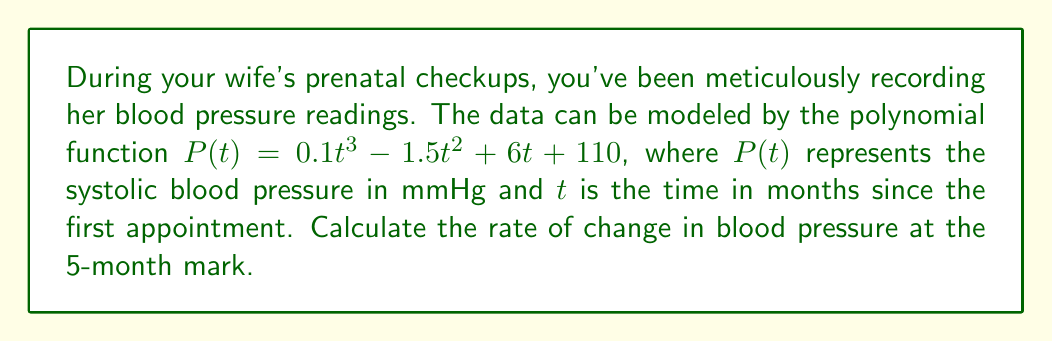Provide a solution to this math problem. To find the rate of change in blood pressure at a specific time, we need to calculate the derivative of the given function and evaluate it at the desired point.

Step 1: Find the derivative of $P(t)$.
$$P'(t) = \frac{d}{dt}(0.1t^3 - 1.5t^2 + 6t + 110)$$
$$P'(t) = 0.3t^2 - 3t + 6$$

Step 2: Evaluate the derivative at $t = 5$ months.
$$P'(5) = 0.3(5)^2 - 3(5) + 6$$
$$P'(5) = 0.3(25) - 15 + 6$$
$$P'(5) = 7.5 - 15 + 6$$
$$P'(5) = -1.5$$

The rate of change is negative, indicating a decrease in blood pressure at this point.
Answer: $-1.5$ mmHg/month 